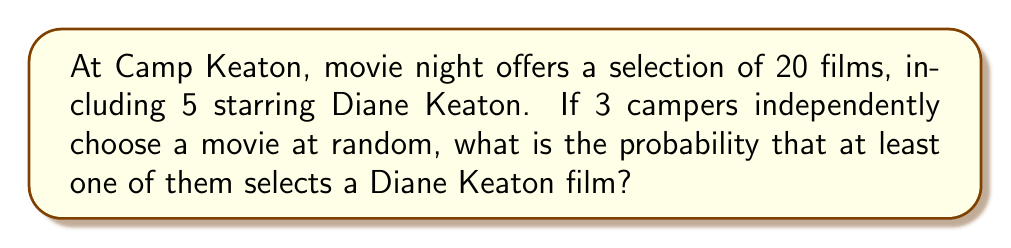Can you answer this question? Let's approach this step-by-step:

1) First, let's calculate the probability of a single camper choosing a Diane Keaton movie:
   $P(\text{Keaton}) = \frac{5}{20} = \frac{1}{4}$

2) The probability of a camper not choosing a Keaton movie is:
   $P(\text{Not Keaton}) = 1 - \frac{1}{4} = \frac{3}{4}$

3) For no camper to choose a Keaton movie, all three must choose non-Keaton movies:
   $P(\text{No Keaton}) = (\frac{3}{4})^3 = \frac{27}{64}$

4) The probability of at least one camper choosing a Keaton movie is the complement of no one choosing a Keaton movie:
   $P(\text{At least one Keaton}) = 1 - P(\text{No Keaton})$
   $= 1 - \frac{27}{64} = \frac{64}{64} - \frac{27}{64} = \frac{37}{64}$

5) We can also calculate this using the inclusion-exclusion principle:
   $$\begin{align*}
   P(\text{At least one}) &= P(A \cup B \cup C) \\
   &= P(A) + P(B) + P(C) - P(A \cap B) - P(A \cap C) - P(B \cap C) + P(A \cap B \cap C) \\
   &= 3(\frac{1}{4}) - 3(\frac{1}{4})^2 + (\frac{1}{4})^3 \\
   &= \frac{3}{4} - \frac{3}{16} + \frac{1}{64} \\
   &= \frac{48}{64} - \frac{12}{64} + \frac{1}{64} = \frac{37}{64}
   \end{align*}$$

Both methods yield the same result.
Answer: $\frac{37}{64}$ or approximately 0.578125 